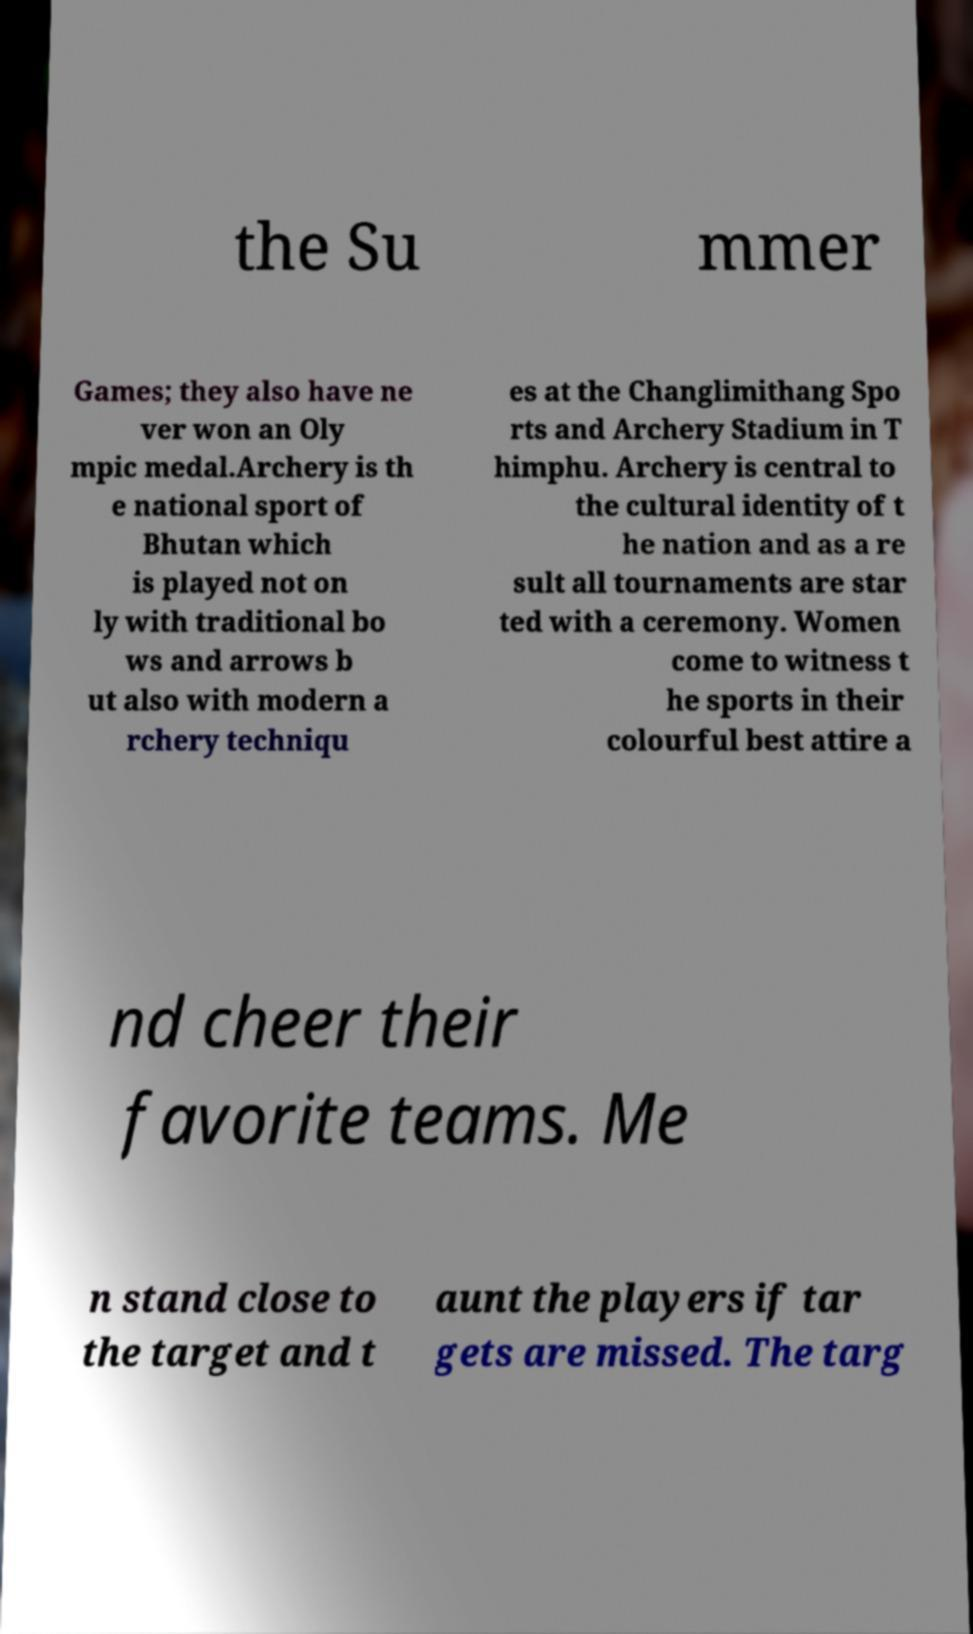Can you read and provide the text displayed in the image?This photo seems to have some interesting text. Can you extract and type it out for me? the Su mmer Games; they also have ne ver won an Oly mpic medal.Archery is th e national sport of Bhutan which is played not on ly with traditional bo ws and arrows b ut also with modern a rchery techniqu es at the Changlimithang Spo rts and Archery Stadium in T himphu. Archery is central to the cultural identity of t he nation and as a re sult all tournaments are star ted with a ceremony. Women come to witness t he sports in their colourful best attire a nd cheer their favorite teams. Me n stand close to the target and t aunt the players if tar gets are missed. The targ 